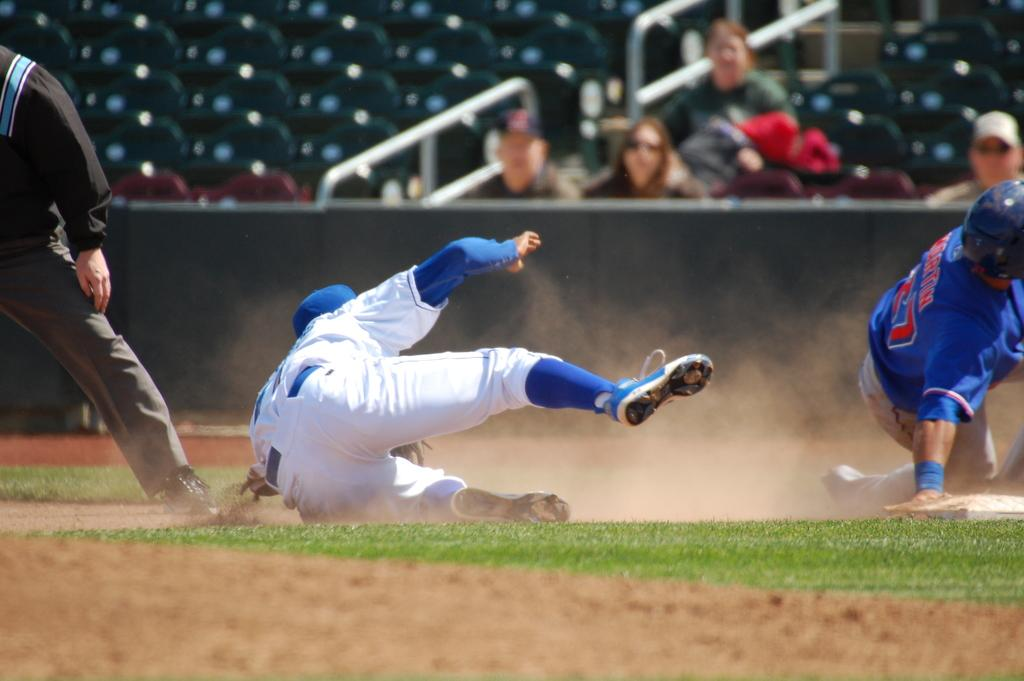What activity are the people on the ground engaged in? The people on the ground are playing a game. What can be seen in the background of the image? There are people sitting in chairs in the background. How many chairs are visible in the image? There are empty chairs visible in the image. What type of brick is being used to start a fire in the image? There is no brick or fire present in the image; it features people playing a game on the ground and people sitting in chairs in the background. 